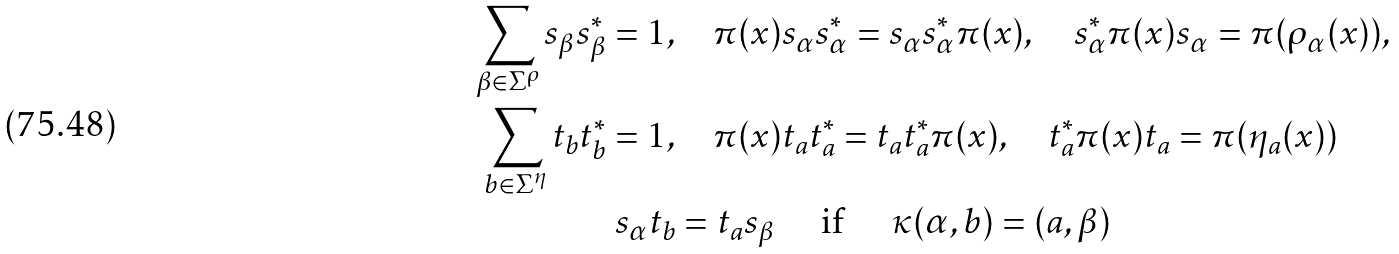Convert formula to latex. <formula><loc_0><loc_0><loc_500><loc_500>\sum _ { \beta \in \Sigma ^ { \rho } } s _ { \beta } s _ { \beta } ^ { * } = 1 , & \quad \pi ( x ) s _ { \alpha } s _ { \alpha } ^ { * } = s _ { \alpha } s _ { \alpha } ^ { * } \pi ( x ) , \quad s _ { \alpha } ^ { * } \pi ( x ) s _ { \alpha } = \pi ( \rho _ { \alpha } ( x ) ) , \\ \sum _ { b \in \Sigma ^ { \eta } } t _ { b } t _ { b } ^ { * } = 1 , & \quad \pi ( x ) t _ { a } t _ { a } ^ { * } = t _ { a } t _ { a } ^ { * } \pi ( x ) , \quad t _ { a } ^ { * } \pi ( x ) t _ { a } = \pi ( \eta _ { a } ( x ) ) \\ s _ { \alpha } t _ { b } & = t _ { a } s _ { \beta } \quad \text { if } \quad \kappa ( \alpha , b ) = ( a , \beta )</formula> 